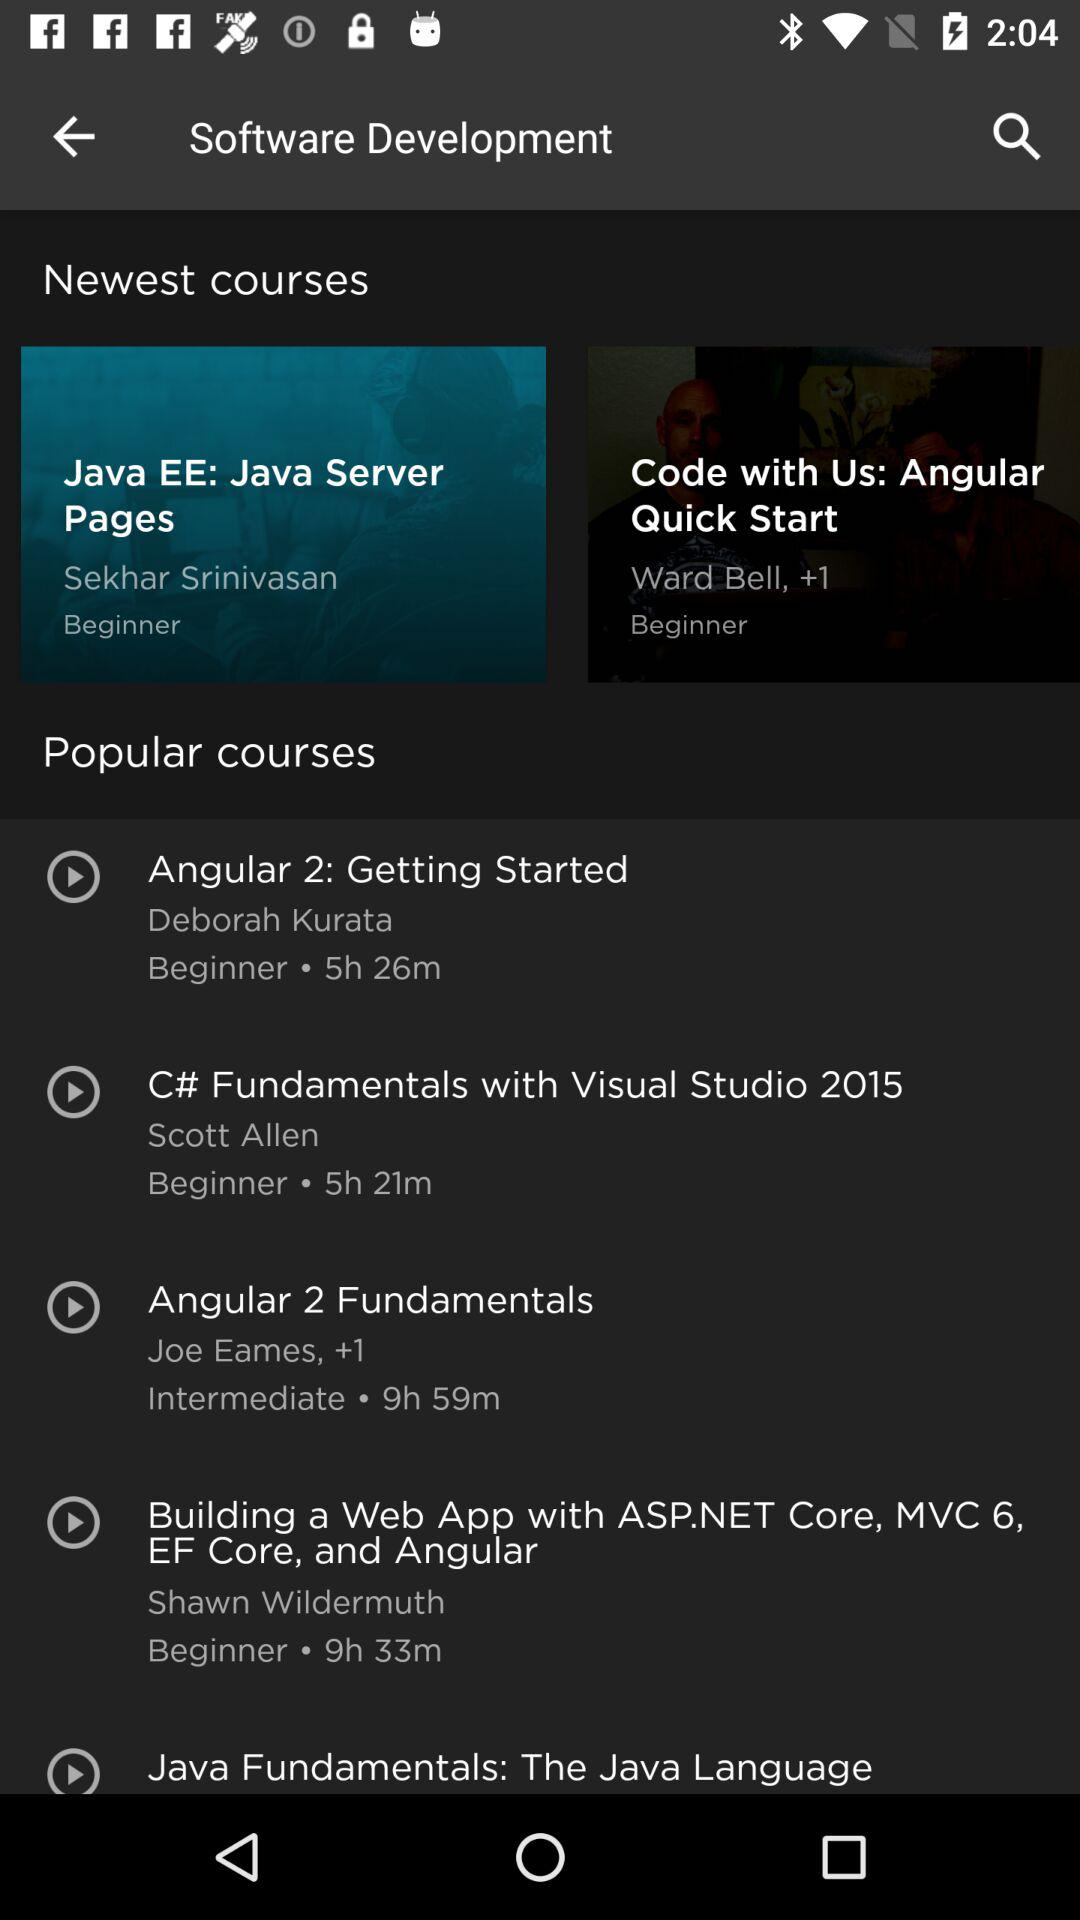What is the duration of "Angular 2 Fundamentals"? The duration is 9 hours and 59 minutes. 